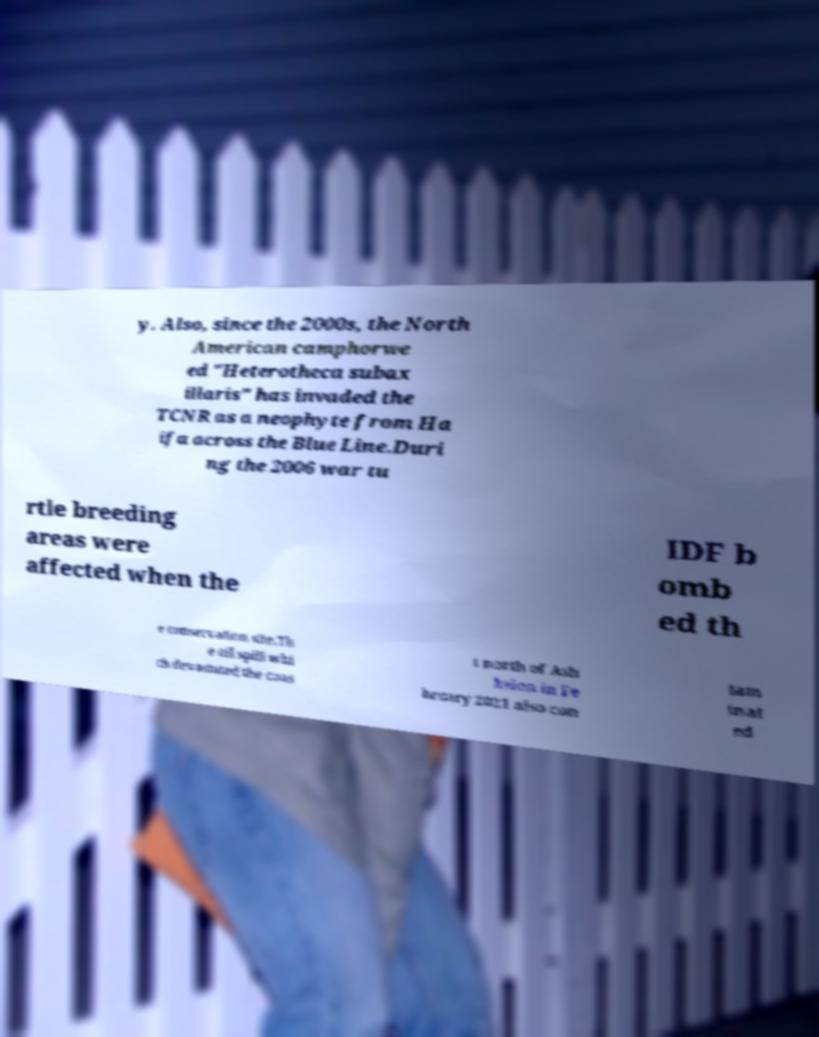Please read and relay the text visible in this image. What does it say? y. Also, since the 2000s, the North American camphorwe ed "Heterotheca subax illaris" has invaded the TCNR as a neophyte from Ha ifa across the Blue Line.Duri ng the 2006 war tu rtle breeding areas were affected when the IDF b omb ed th e conservation site.Th e oil spill whi ch devastated the coas t north of Ash kelon in Fe bruary 2021 also con tam inat ed 